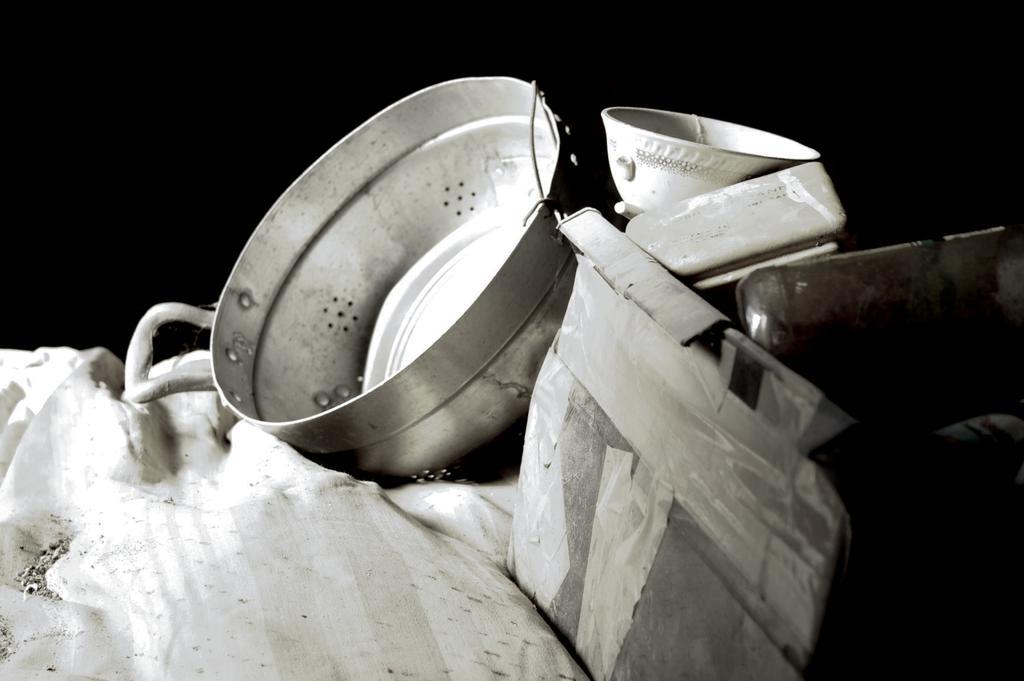Please provide a concise description of this image. This is a black and white image. In this image we can see a cloth, vessel, bowl and some other items. In the background it is dark. 